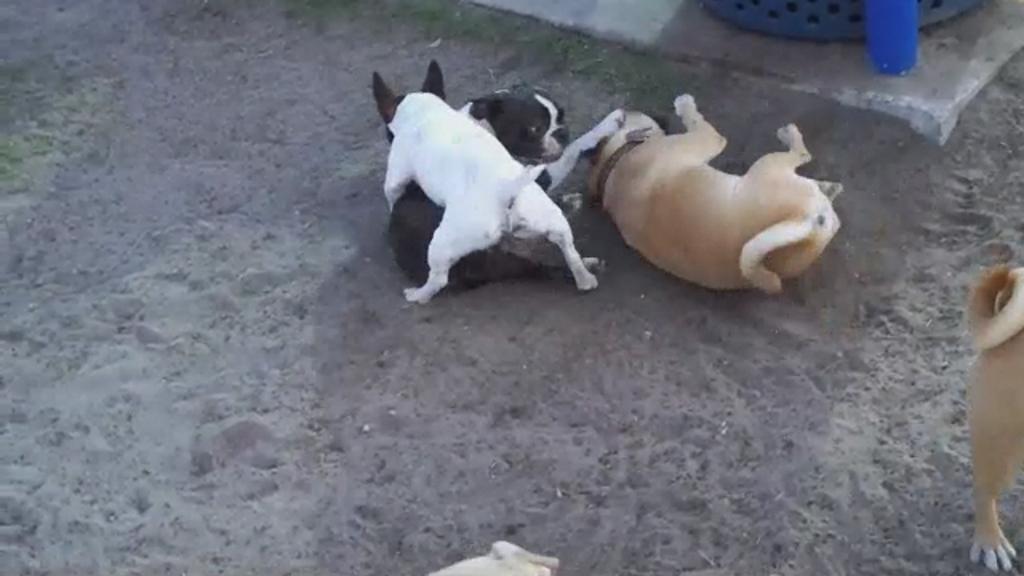How would you summarize this image in a sentence or two? As we can see in the image there are different colors of dogs. These two dogs are in brown color. This dog is in white color color and the other is in black color. 